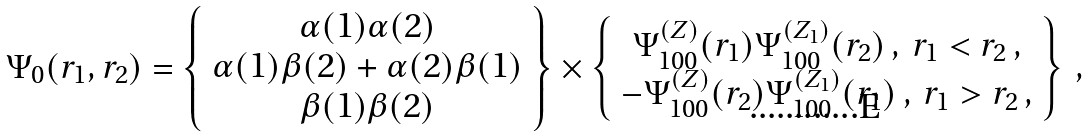Convert formula to latex. <formula><loc_0><loc_0><loc_500><loc_500>\Psi _ { 0 } ( { r } _ { 1 } , { r } _ { 2 } ) = \left \{ \begin{array} { c } \alpha ( 1 ) \alpha ( 2 ) \\ \alpha ( 1 ) \beta ( 2 ) + \alpha ( 2 ) \beta ( 1 ) \\ \beta ( 1 ) \beta ( 2 ) \end{array} \right \} \times \left \{ \begin{array} { c } \Psi _ { 1 0 0 } ^ { ( Z ) } ( { r } _ { 1 } ) \Psi _ { 1 0 0 } ^ { ( Z _ { 1 } ) } ( { r } _ { 2 } ) \, , \, r _ { 1 } < r _ { 2 } \, , \\ - \Psi _ { 1 0 0 } ^ { ( Z ) } ( { r } _ { 2 } ) \Psi _ { 1 0 0 } ^ { ( Z _ { 1 } ) } ( { r } _ { 1 } ) \, , \, r _ { 1 } > r _ { 2 } \, , \end{array} \right \} \, ,</formula> 